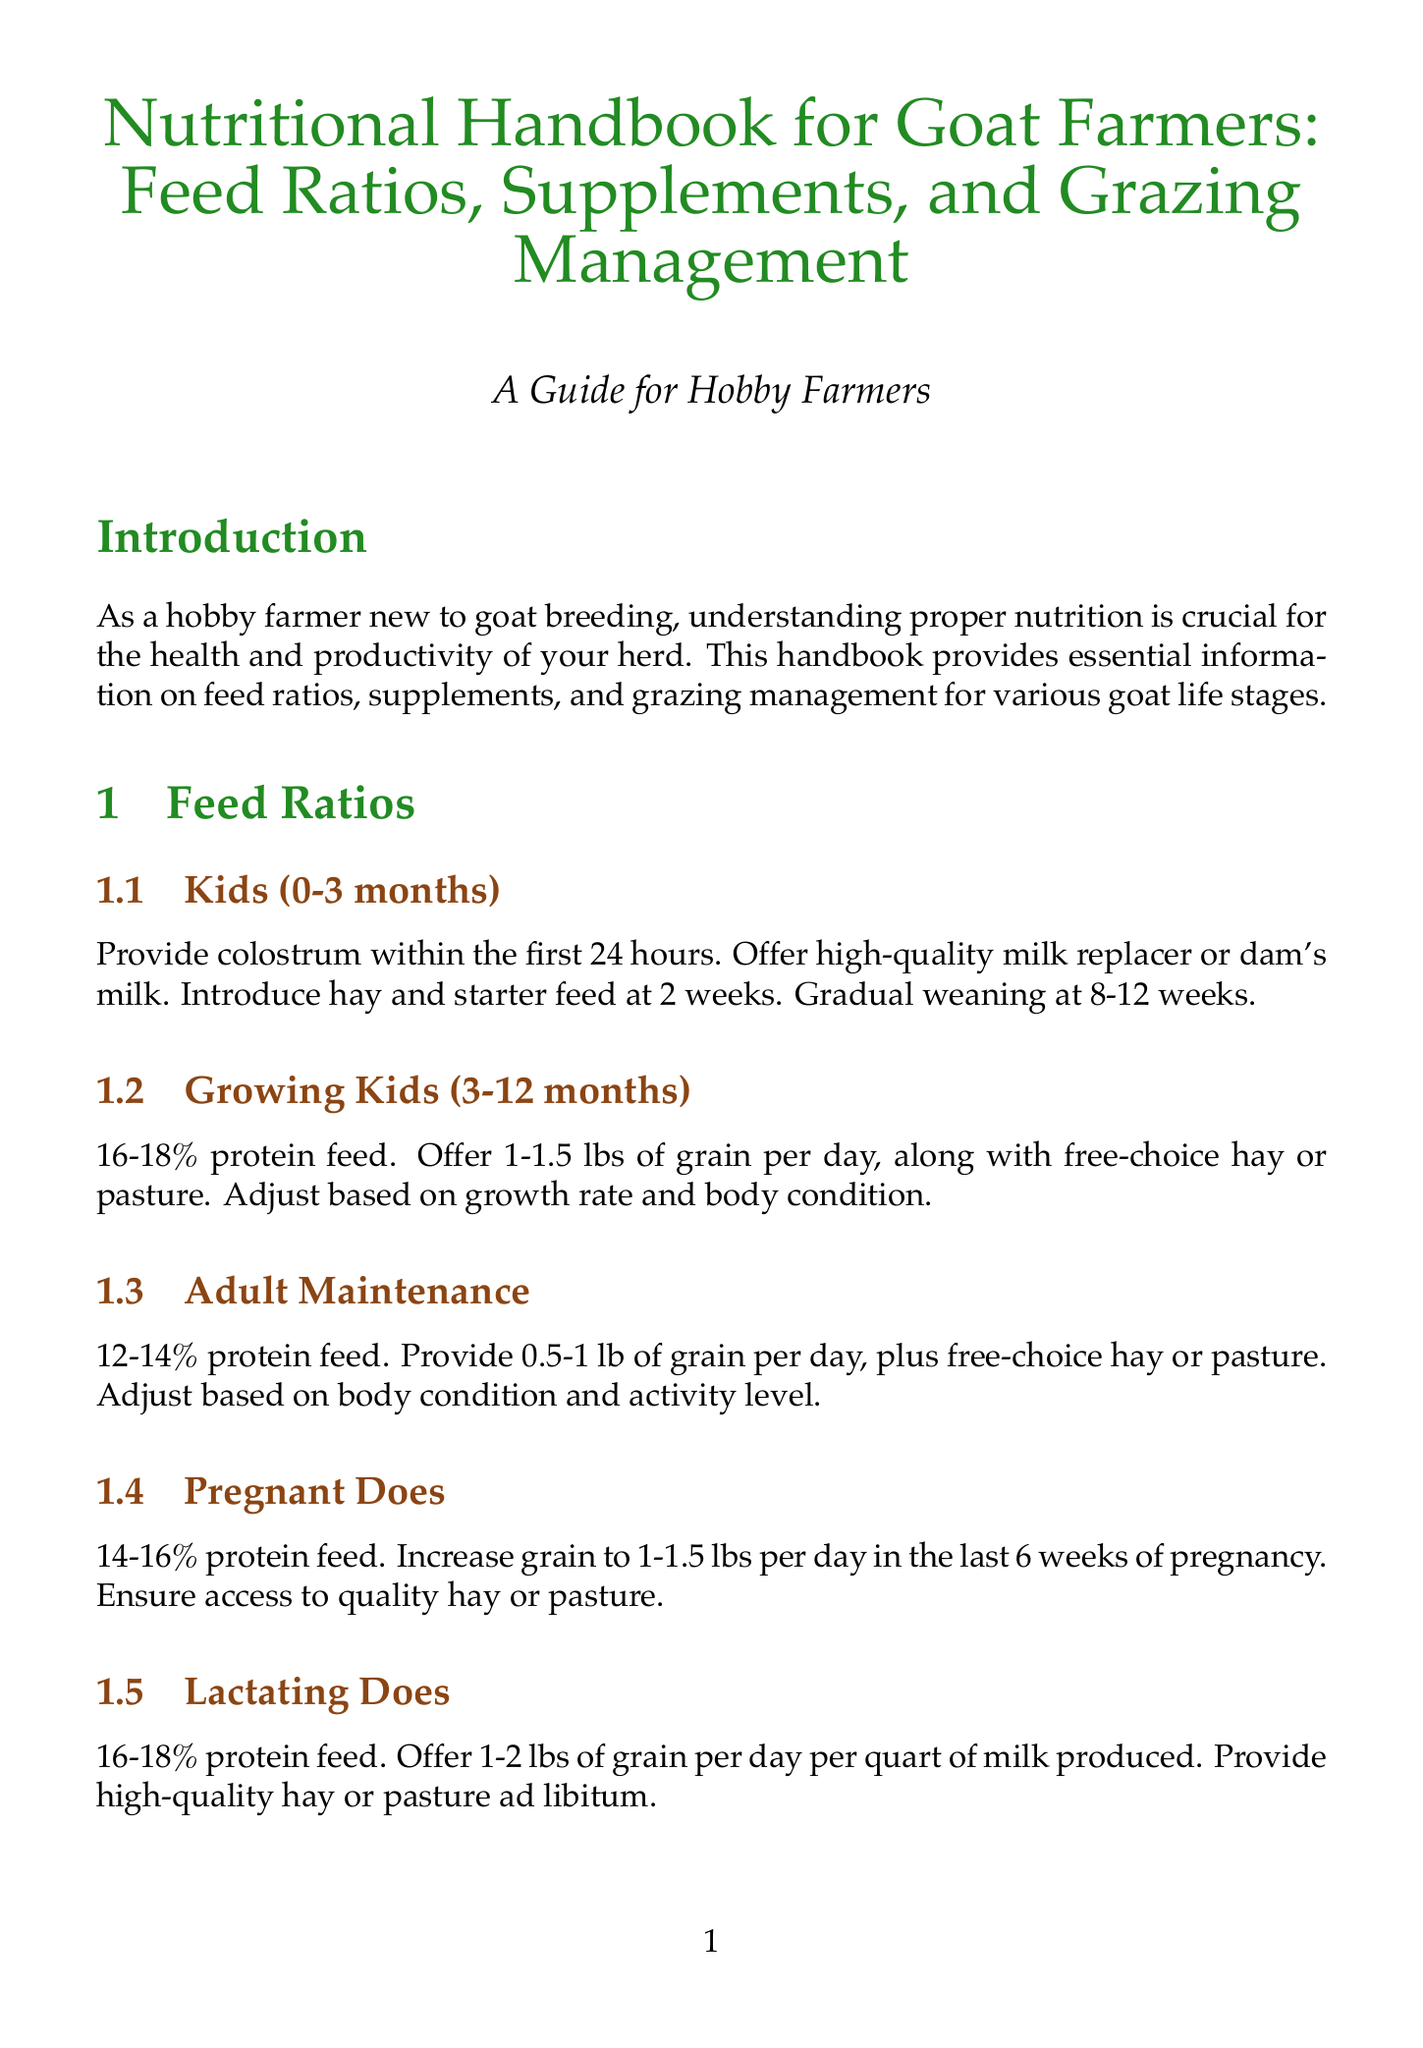What is the protein percentage for lactating does? The document states that lactating does require a feed with 16-18% protein.
Answer: 16-18% How often should goats be moved to fresh pasture? According to the document, goats should be moved to fresh pasture every 7-14 days.
Answer: 7-14 days What type of mineral mix should be offered to goats? The document recommends offering a goat-specific mineral mix containing copper, selenium, and zinc.
Answer: Goat-specific mineral mix What is the daily grain recommendation for adult maintenance? The document suggests providing 0.5-1 lb of grain per day for adult maintenance.
Answer: 0.5-1 lb What type of forage diversity should be offered? The document advises offering a variety of forages such as grasses, legumes, and browse.
Answer: Grasses, legumes, and browse What essential vitamins should be ensured for goats? The document states that vitamin A, D, and E should be ensured for goats.
Answer: Vitamins A, D, and E What is the primary purpose of probiotics for goats? Probiotics are beneficial for digestive health, especially during feed changes or stress.
Answer: Digestive health What should be monitored for signs of nutritional deficiencies? According to the document, body condition scores should be regularly assessed for nutritional deficiencies.
Answer: Body condition scores What additional supplementation might dairy breeds require? The document mentions that dairy breeds may need additional calcium supplementation.
Answer: Additional calcium supplementation 